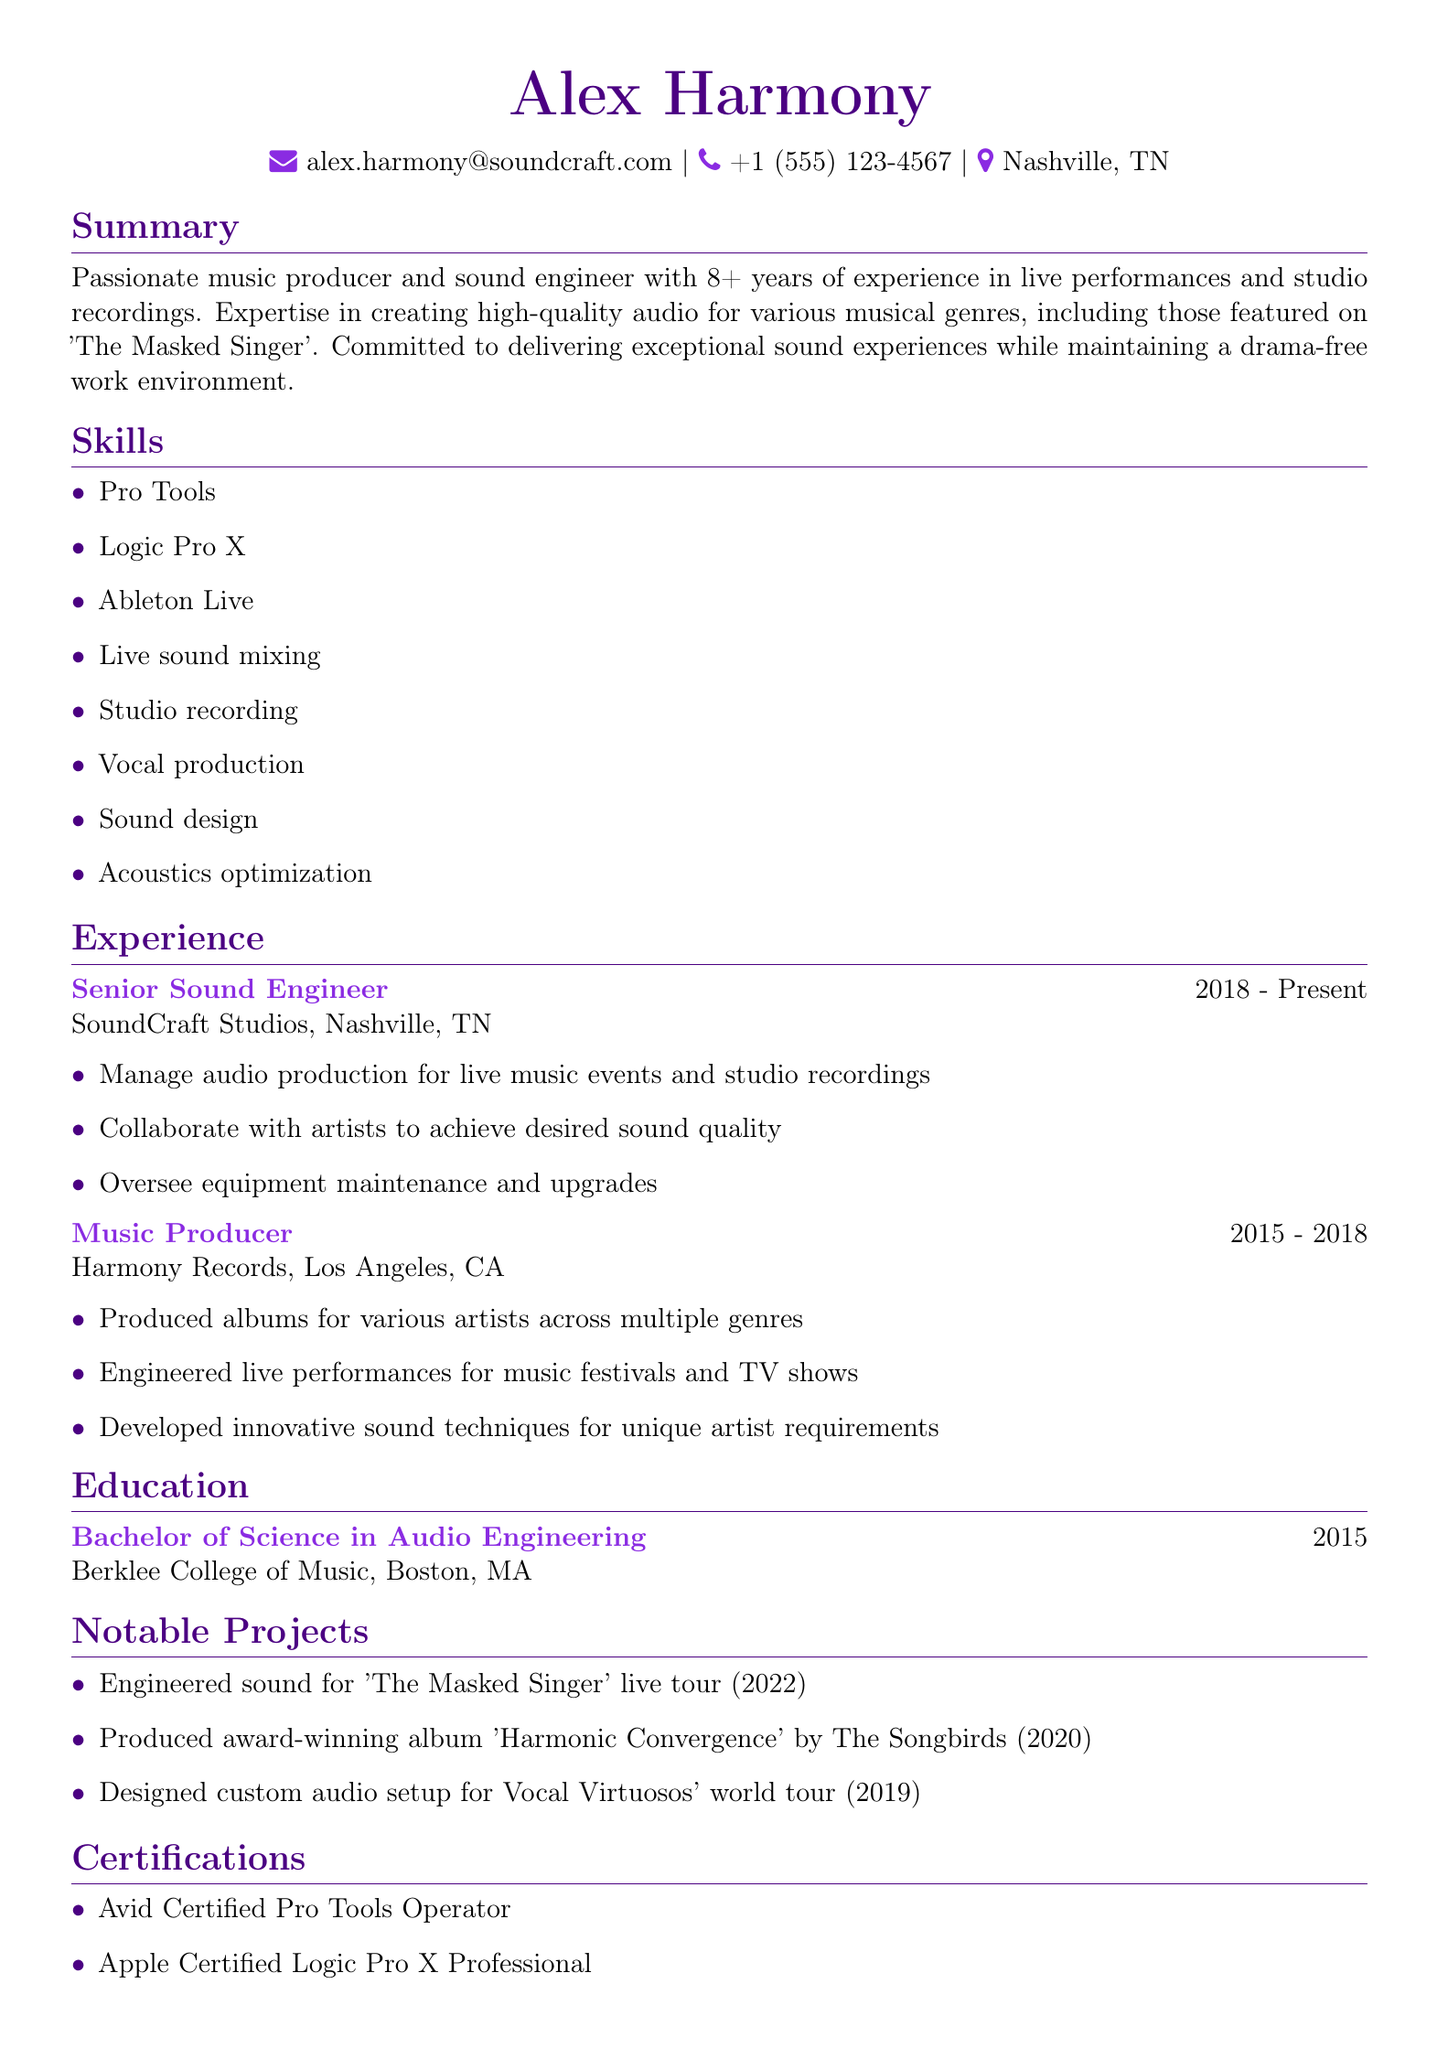What is the name of the candidate? The candidate's name is listed at the top of the document.
Answer: Alex Harmony What is the location of the candidate? The location is specified in the personal information section.
Answer: Nashville, TN How many years of experience does the candidate have? The candidate's experience duration is stated in the summary.
Answer: 8+ What is the highest degree obtained by the candidate? The highest degree is mentioned in the education section.
Answer: Bachelor of Science in Audio Engineering What company did the candidate work for as a Senior Sound Engineer? The company is identified under the experience section for the relevant job title.
Answer: SoundCraft Studios In what year did the candidate graduate? The graduation year is provided in the education section.
Answer: 2015 How many certifications does the candidate have listed? The total number of certifications is found in the certifications section.
Answer: 2 What project involved engineering sound for 'The Masked Singer'? The relevant project is noted in the notable projects section.
Answer: Engineered sound for 'The Masked Singer' live tour (2022) Which software is the candidate certified in for audio production? The specific certification is listed in the certifications section.
Answer: Pro Tools 